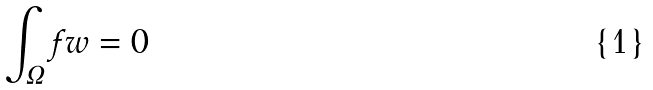<formula> <loc_0><loc_0><loc_500><loc_500>\int _ { \Omega } f w = 0</formula> 